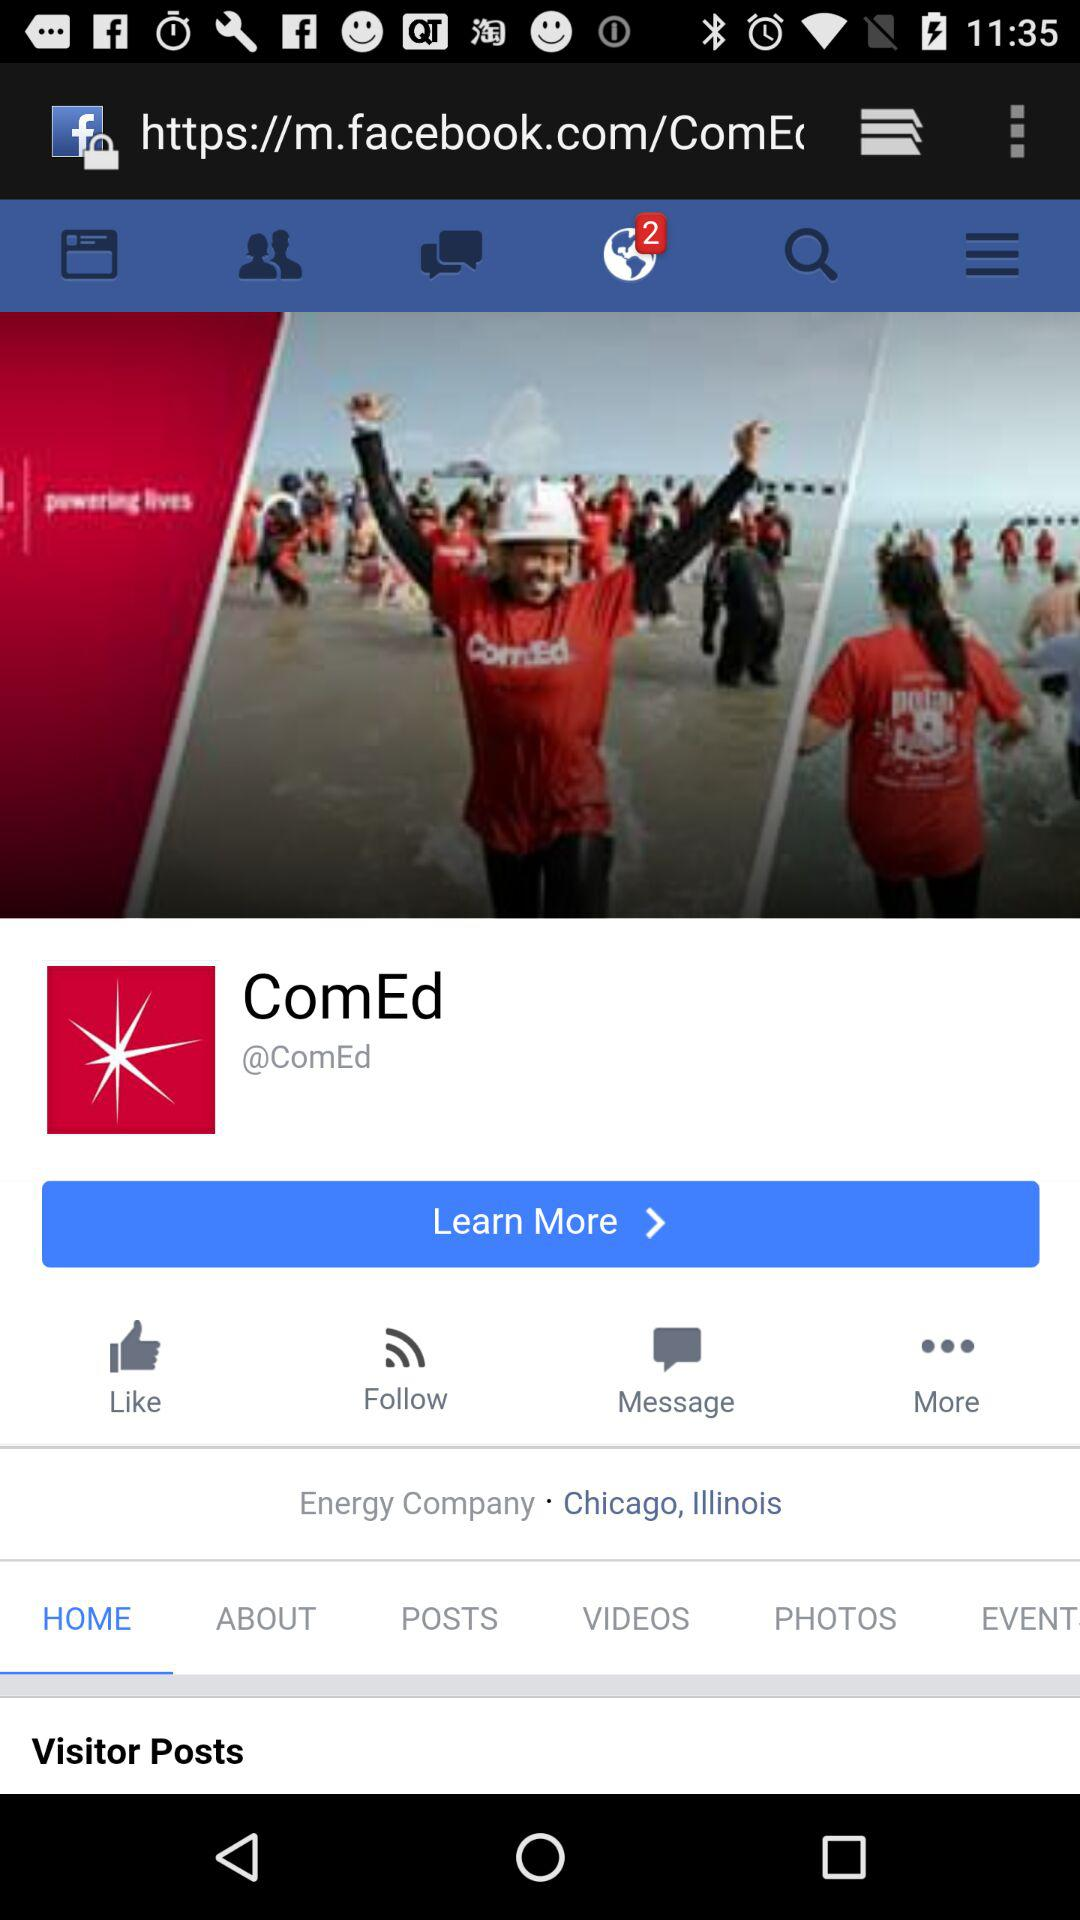Which tab is selected? The selected tab is "HOME". 